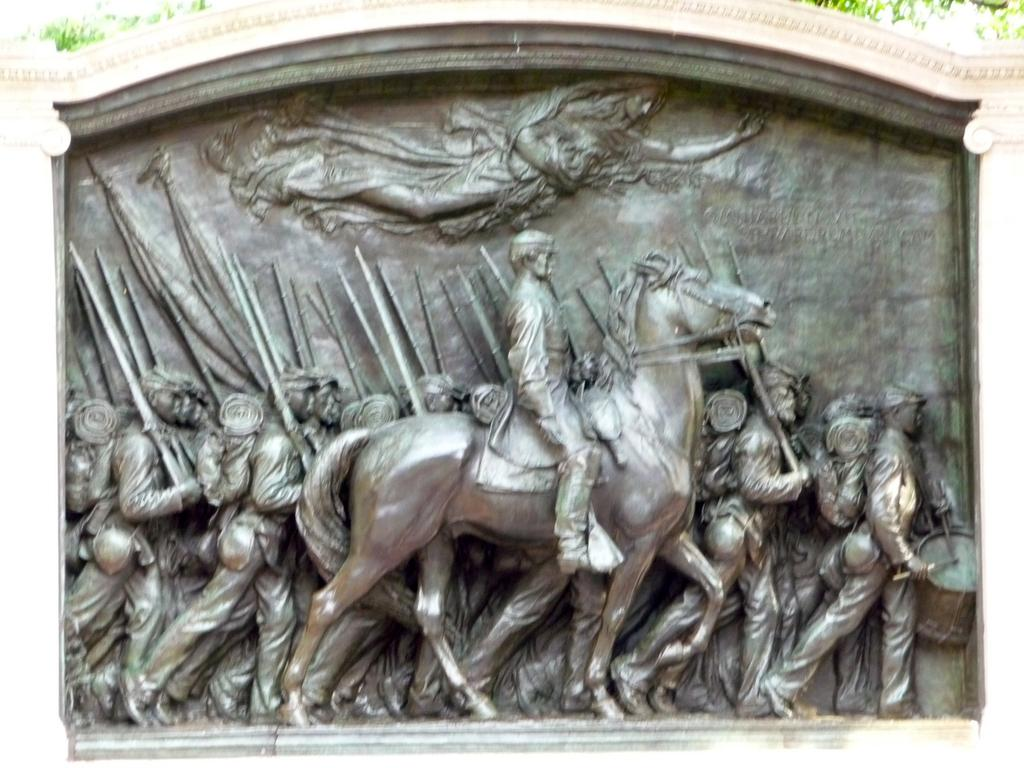What is the main subject of the image? There is a sculpture in the image. What does the sculpture depict? The sculpture depicts a person sitting on a horse. Are there any other people or objects in the image? Yes, there is a group of people walking in the image. How many cows can be seen grazing on the top of the sculpture in the image? There are no cows present in the image, and the sculpture does not have a top where cows could graze. 